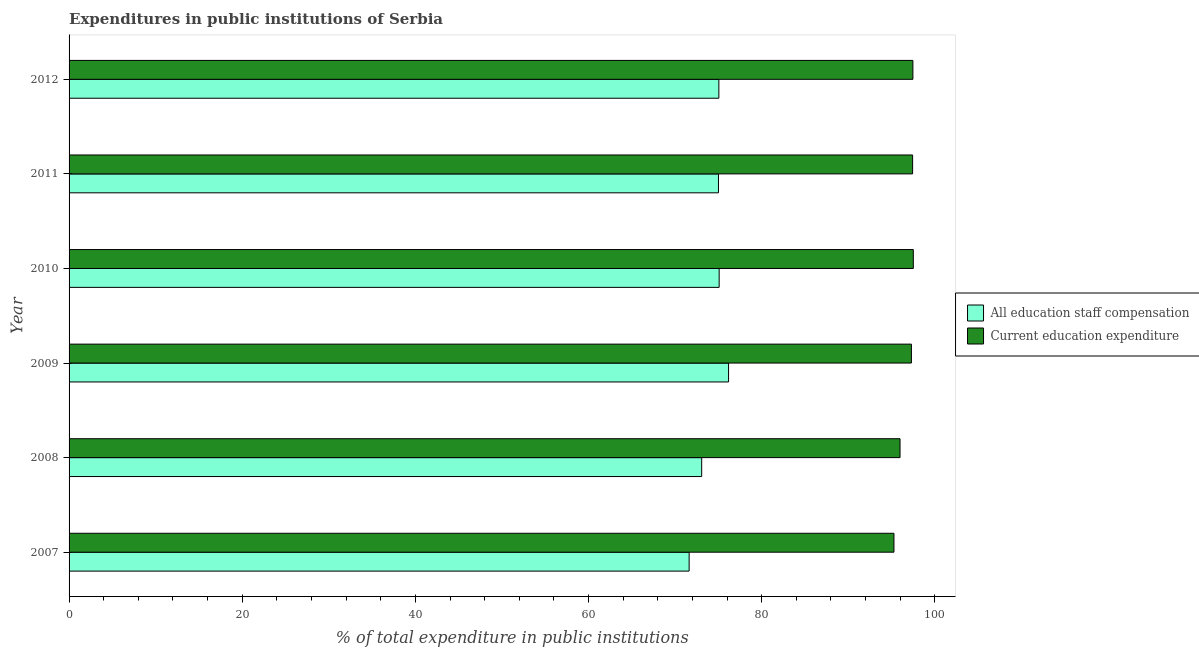Are the number of bars per tick equal to the number of legend labels?
Give a very brief answer. Yes. Are the number of bars on each tick of the Y-axis equal?
Offer a very short reply. Yes. In how many cases, is the number of bars for a given year not equal to the number of legend labels?
Provide a succinct answer. 0. What is the expenditure in education in 2011?
Give a very brief answer. 97.43. Across all years, what is the maximum expenditure in staff compensation?
Your answer should be very brief. 76.18. Across all years, what is the minimum expenditure in staff compensation?
Offer a very short reply. 71.62. In which year was the expenditure in education maximum?
Make the answer very short. 2010. In which year was the expenditure in education minimum?
Your answer should be very brief. 2007. What is the total expenditure in staff compensation in the graph?
Your answer should be very brief. 446.02. What is the difference between the expenditure in staff compensation in 2009 and that in 2011?
Give a very brief answer. 1.17. What is the difference between the expenditure in staff compensation in 2011 and the expenditure in education in 2010?
Give a very brief answer. -22.51. What is the average expenditure in education per year?
Ensure brevity in your answer.  96.83. In the year 2010, what is the difference between the expenditure in education and expenditure in staff compensation?
Provide a succinct answer. 22.43. What is the ratio of the expenditure in staff compensation in 2007 to that in 2011?
Offer a very short reply. 0.95. Is the expenditure in education in 2010 less than that in 2011?
Provide a short and direct response. No. What is the difference between the highest and the second highest expenditure in education?
Offer a terse response. 0.05. What is the difference between the highest and the lowest expenditure in education?
Offer a very short reply. 2.24. What does the 2nd bar from the top in 2008 represents?
Offer a terse response. All education staff compensation. What does the 2nd bar from the bottom in 2011 represents?
Your answer should be very brief. Current education expenditure. How many bars are there?
Offer a very short reply. 12. Are the values on the major ticks of X-axis written in scientific E-notation?
Your answer should be compact. No. Does the graph contain any zero values?
Make the answer very short. No. Where does the legend appear in the graph?
Provide a short and direct response. Center right. How many legend labels are there?
Your answer should be very brief. 2. What is the title of the graph?
Make the answer very short. Expenditures in public institutions of Serbia. Does "Overweight" appear as one of the legend labels in the graph?
Provide a succinct answer. No. What is the label or title of the X-axis?
Offer a very short reply. % of total expenditure in public institutions. What is the label or title of the Y-axis?
Keep it short and to the point. Year. What is the % of total expenditure in public institutions in All education staff compensation in 2007?
Provide a short and direct response. 71.62. What is the % of total expenditure in public institutions in Current education expenditure in 2007?
Your answer should be very brief. 95.28. What is the % of total expenditure in public institutions in All education staff compensation in 2008?
Your answer should be compact. 73.07. What is the % of total expenditure in public institutions in Current education expenditure in 2008?
Your answer should be compact. 95.98. What is the % of total expenditure in public institutions of All education staff compensation in 2009?
Your response must be concise. 76.18. What is the % of total expenditure in public institutions of Current education expenditure in 2009?
Your answer should be very brief. 97.29. What is the % of total expenditure in public institutions of All education staff compensation in 2010?
Ensure brevity in your answer.  75.09. What is the % of total expenditure in public institutions of Current education expenditure in 2010?
Make the answer very short. 97.51. What is the % of total expenditure in public institutions in All education staff compensation in 2011?
Make the answer very short. 75.01. What is the % of total expenditure in public institutions in Current education expenditure in 2011?
Your response must be concise. 97.43. What is the % of total expenditure in public institutions in All education staff compensation in 2012?
Keep it short and to the point. 75.06. What is the % of total expenditure in public institutions in Current education expenditure in 2012?
Make the answer very short. 97.47. Across all years, what is the maximum % of total expenditure in public institutions of All education staff compensation?
Your response must be concise. 76.18. Across all years, what is the maximum % of total expenditure in public institutions in Current education expenditure?
Ensure brevity in your answer.  97.51. Across all years, what is the minimum % of total expenditure in public institutions in All education staff compensation?
Give a very brief answer. 71.62. Across all years, what is the minimum % of total expenditure in public institutions in Current education expenditure?
Keep it short and to the point. 95.28. What is the total % of total expenditure in public institutions of All education staff compensation in the graph?
Keep it short and to the point. 446.02. What is the total % of total expenditure in public institutions in Current education expenditure in the graph?
Provide a succinct answer. 580.97. What is the difference between the % of total expenditure in public institutions of All education staff compensation in 2007 and that in 2008?
Ensure brevity in your answer.  -1.45. What is the difference between the % of total expenditure in public institutions of Current education expenditure in 2007 and that in 2008?
Provide a succinct answer. -0.7. What is the difference between the % of total expenditure in public institutions of All education staff compensation in 2007 and that in 2009?
Offer a very short reply. -4.55. What is the difference between the % of total expenditure in public institutions of Current education expenditure in 2007 and that in 2009?
Make the answer very short. -2.01. What is the difference between the % of total expenditure in public institutions in All education staff compensation in 2007 and that in 2010?
Your response must be concise. -3.47. What is the difference between the % of total expenditure in public institutions of Current education expenditure in 2007 and that in 2010?
Offer a terse response. -2.24. What is the difference between the % of total expenditure in public institutions in All education staff compensation in 2007 and that in 2011?
Provide a succinct answer. -3.39. What is the difference between the % of total expenditure in public institutions in Current education expenditure in 2007 and that in 2011?
Your response must be concise. -2.15. What is the difference between the % of total expenditure in public institutions in All education staff compensation in 2007 and that in 2012?
Your answer should be very brief. -3.43. What is the difference between the % of total expenditure in public institutions of Current education expenditure in 2007 and that in 2012?
Your answer should be compact. -2.19. What is the difference between the % of total expenditure in public institutions of All education staff compensation in 2008 and that in 2009?
Make the answer very short. -3.1. What is the difference between the % of total expenditure in public institutions in Current education expenditure in 2008 and that in 2009?
Offer a terse response. -1.31. What is the difference between the % of total expenditure in public institutions of All education staff compensation in 2008 and that in 2010?
Your response must be concise. -2.02. What is the difference between the % of total expenditure in public institutions in Current education expenditure in 2008 and that in 2010?
Keep it short and to the point. -1.53. What is the difference between the % of total expenditure in public institutions of All education staff compensation in 2008 and that in 2011?
Your answer should be very brief. -1.94. What is the difference between the % of total expenditure in public institutions in Current education expenditure in 2008 and that in 2011?
Ensure brevity in your answer.  -1.45. What is the difference between the % of total expenditure in public institutions in All education staff compensation in 2008 and that in 2012?
Your answer should be compact. -1.98. What is the difference between the % of total expenditure in public institutions in Current education expenditure in 2008 and that in 2012?
Your answer should be very brief. -1.49. What is the difference between the % of total expenditure in public institutions of All education staff compensation in 2009 and that in 2010?
Offer a very short reply. 1.09. What is the difference between the % of total expenditure in public institutions in Current education expenditure in 2009 and that in 2010?
Make the answer very short. -0.22. What is the difference between the % of total expenditure in public institutions in All education staff compensation in 2009 and that in 2011?
Offer a very short reply. 1.17. What is the difference between the % of total expenditure in public institutions in Current education expenditure in 2009 and that in 2011?
Offer a very short reply. -0.14. What is the difference between the % of total expenditure in public institutions in All education staff compensation in 2009 and that in 2012?
Offer a terse response. 1.12. What is the difference between the % of total expenditure in public institutions of Current education expenditure in 2009 and that in 2012?
Provide a succinct answer. -0.17. What is the difference between the % of total expenditure in public institutions of Current education expenditure in 2010 and that in 2011?
Your response must be concise. 0.08. What is the difference between the % of total expenditure in public institutions in All education staff compensation in 2010 and that in 2012?
Provide a succinct answer. 0.03. What is the difference between the % of total expenditure in public institutions in Current education expenditure in 2010 and that in 2012?
Your answer should be compact. 0.05. What is the difference between the % of total expenditure in public institutions in All education staff compensation in 2011 and that in 2012?
Your response must be concise. -0.05. What is the difference between the % of total expenditure in public institutions of Current education expenditure in 2011 and that in 2012?
Make the answer very short. -0.03. What is the difference between the % of total expenditure in public institutions in All education staff compensation in 2007 and the % of total expenditure in public institutions in Current education expenditure in 2008?
Give a very brief answer. -24.36. What is the difference between the % of total expenditure in public institutions in All education staff compensation in 2007 and the % of total expenditure in public institutions in Current education expenditure in 2009?
Your response must be concise. -25.67. What is the difference between the % of total expenditure in public institutions in All education staff compensation in 2007 and the % of total expenditure in public institutions in Current education expenditure in 2010?
Offer a terse response. -25.89. What is the difference between the % of total expenditure in public institutions of All education staff compensation in 2007 and the % of total expenditure in public institutions of Current education expenditure in 2011?
Make the answer very short. -25.81. What is the difference between the % of total expenditure in public institutions of All education staff compensation in 2007 and the % of total expenditure in public institutions of Current education expenditure in 2012?
Your answer should be compact. -25.84. What is the difference between the % of total expenditure in public institutions in All education staff compensation in 2008 and the % of total expenditure in public institutions in Current education expenditure in 2009?
Provide a short and direct response. -24.22. What is the difference between the % of total expenditure in public institutions in All education staff compensation in 2008 and the % of total expenditure in public institutions in Current education expenditure in 2010?
Provide a succinct answer. -24.44. What is the difference between the % of total expenditure in public institutions of All education staff compensation in 2008 and the % of total expenditure in public institutions of Current education expenditure in 2011?
Your answer should be very brief. -24.36. What is the difference between the % of total expenditure in public institutions of All education staff compensation in 2008 and the % of total expenditure in public institutions of Current education expenditure in 2012?
Give a very brief answer. -24.4. What is the difference between the % of total expenditure in public institutions of All education staff compensation in 2009 and the % of total expenditure in public institutions of Current education expenditure in 2010?
Your answer should be very brief. -21.34. What is the difference between the % of total expenditure in public institutions of All education staff compensation in 2009 and the % of total expenditure in public institutions of Current education expenditure in 2011?
Provide a short and direct response. -21.26. What is the difference between the % of total expenditure in public institutions of All education staff compensation in 2009 and the % of total expenditure in public institutions of Current education expenditure in 2012?
Keep it short and to the point. -21.29. What is the difference between the % of total expenditure in public institutions of All education staff compensation in 2010 and the % of total expenditure in public institutions of Current education expenditure in 2011?
Provide a short and direct response. -22.34. What is the difference between the % of total expenditure in public institutions of All education staff compensation in 2010 and the % of total expenditure in public institutions of Current education expenditure in 2012?
Offer a very short reply. -22.38. What is the difference between the % of total expenditure in public institutions in All education staff compensation in 2011 and the % of total expenditure in public institutions in Current education expenditure in 2012?
Offer a very short reply. -22.46. What is the average % of total expenditure in public institutions of All education staff compensation per year?
Offer a terse response. 74.34. What is the average % of total expenditure in public institutions of Current education expenditure per year?
Give a very brief answer. 96.83. In the year 2007, what is the difference between the % of total expenditure in public institutions in All education staff compensation and % of total expenditure in public institutions in Current education expenditure?
Keep it short and to the point. -23.66. In the year 2008, what is the difference between the % of total expenditure in public institutions of All education staff compensation and % of total expenditure in public institutions of Current education expenditure?
Ensure brevity in your answer.  -22.91. In the year 2009, what is the difference between the % of total expenditure in public institutions of All education staff compensation and % of total expenditure in public institutions of Current education expenditure?
Make the answer very short. -21.12. In the year 2010, what is the difference between the % of total expenditure in public institutions in All education staff compensation and % of total expenditure in public institutions in Current education expenditure?
Your answer should be very brief. -22.43. In the year 2011, what is the difference between the % of total expenditure in public institutions in All education staff compensation and % of total expenditure in public institutions in Current education expenditure?
Your response must be concise. -22.42. In the year 2012, what is the difference between the % of total expenditure in public institutions in All education staff compensation and % of total expenditure in public institutions in Current education expenditure?
Keep it short and to the point. -22.41. What is the ratio of the % of total expenditure in public institutions of All education staff compensation in 2007 to that in 2008?
Offer a very short reply. 0.98. What is the ratio of the % of total expenditure in public institutions of All education staff compensation in 2007 to that in 2009?
Provide a short and direct response. 0.94. What is the ratio of the % of total expenditure in public institutions of Current education expenditure in 2007 to that in 2009?
Provide a succinct answer. 0.98. What is the ratio of the % of total expenditure in public institutions in All education staff compensation in 2007 to that in 2010?
Offer a terse response. 0.95. What is the ratio of the % of total expenditure in public institutions of Current education expenditure in 2007 to that in 2010?
Offer a very short reply. 0.98. What is the ratio of the % of total expenditure in public institutions in All education staff compensation in 2007 to that in 2011?
Your answer should be very brief. 0.95. What is the ratio of the % of total expenditure in public institutions of Current education expenditure in 2007 to that in 2011?
Offer a very short reply. 0.98. What is the ratio of the % of total expenditure in public institutions in All education staff compensation in 2007 to that in 2012?
Give a very brief answer. 0.95. What is the ratio of the % of total expenditure in public institutions in Current education expenditure in 2007 to that in 2012?
Offer a terse response. 0.98. What is the ratio of the % of total expenditure in public institutions of All education staff compensation in 2008 to that in 2009?
Provide a short and direct response. 0.96. What is the ratio of the % of total expenditure in public institutions in Current education expenditure in 2008 to that in 2009?
Provide a succinct answer. 0.99. What is the ratio of the % of total expenditure in public institutions in All education staff compensation in 2008 to that in 2010?
Provide a short and direct response. 0.97. What is the ratio of the % of total expenditure in public institutions of Current education expenditure in 2008 to that in 2010?
Ensure brevity in your answer.  0.98. What is the ratio of the % of total expenditure in public institutions in All education staff compensation in 2008 to that in 2011?
Provide a succinct answer. 0.97. What is the ratio of the % of total expenditure in public institutions in Current education expenditure in 2008 to that in 2011?
Provide a short and direct response. 0.99. What is the ratio of the % of total expenditure in public institutions of All education staff compensation in 2008 to that in 2012?
Provide a succinct answer. 0.97. What is the ratio of the % of total expenditure in public institutions of Current education expenditure in 2008 to that in 2012?
Offer a terse response. 0.98. What is the ratio of the % of total expenditure in public institutions of All education staff compensation in 2009 to that in 2010?
Your answer should be very brief. 1.01. What is the ratio of the % of total expenditure in public institutions in All education staff compensation in 2009 to that in 2011?
Your answer should be compact. 1.02. What is the ratio of the % of total expenditure in public institutions in Current education expenditure in 2009 to that in 2011?
Your answer should be very brief. 1. What is the ratio of the % of total expenditure in public institutions in All education staff compensation in 2009 to that in 2012?
Make the answer very short. 1.01. What is the ratio of the % of total expenditure in public institutions of All education staff compensation in 2010 to that in 2012?
Provide a succinct answer. 1. What is the ratio of the % of total expenditure in public institutions of Current education expenditure in 2010 to that in 2012?
Give a very brief answer. 1. What is the ratio of the % of total expenditure in public institutions of All education staff compensation in 2011 to that in 2012?
Keep it short and to the point. 1. What is the difference between the highest and the second highest % of total expenditure in public institutions in All education staff compensation?
Provide a succinct answer. 1.09. What is the difference between the highest and the second highest % of total expenditure in public institutions of Current education expenditure?
Provide a short and direct response. 0.05. What is the difference between the highest and the lowest % of total expenditure in public institutions of All education staff compensation?
Give a very brief answer. 4.55. What is the difference between the highest and the lowest % of total expenditure in public institutions of Current education expenditure?
Provide a succinct answer. 2.24. 